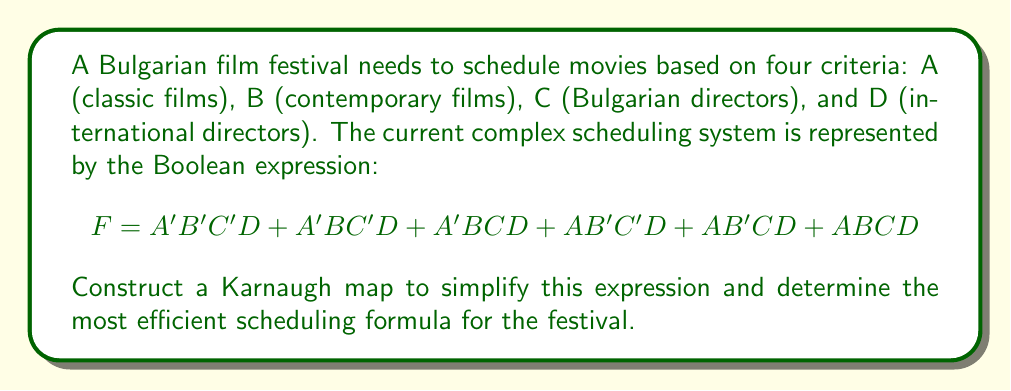Show me your answer to this math problem. Step 1: Create a 4-variable Karnaugh map with 16 cells (4x4 grid).

[asy]
unitsize(1cm);
draw((0,0)--(4,0)--(4,4)--(0,4)--cycle);
draw((0,1)--(4,1));
draw((0,2)--(4,2));
draw((0,3)--(4,3));
draw((1,0)--(1,4));
draw((2,0)--(2,4));
draw((3,0)--(3,4));
label("00", (0.5,4.5));
label("01", (1.5,4.5));
label("11", (2.5,4.5));
label("10", (3.5,4.5));
label("00", (-0.5,3.5));
label("01", (-0.5,2.5));
label("11", (-0.5,1.5));
label("10", (-0.5,0.5));
label("AB", (-0.5,4.5));
label("CD", (4.5,4.5));
[/asy]

Step 2: Fill in the Karnaugh map based on the given expression.

[asy]
unitsize(1cm);
draw((0,0)--(4,0)--(4,4)--(0,4)--cycle);
draw((0,1)--(4,1));
draw((0,2)--(4,2));
draw((0,3)--(4,3));
draw((1,0)--(1,4));
draw((2,0)--(2,4));
draw((3,0)--(3,4));
label("00", (0.5,4.5));
label("01", (1.5,4.5));
label("11", (2.5,4.5));
label("10", (3.5,4.5));
label("00", (-0.5,3.5));
label("01", (-0.5,2.5));
label("11", (-0.5,1.5));
label("10", (-0.5,0.5));
label("AB", (-0.5,4.5));
label("CD", (4.5,4.5));
label("1", (0.5,0.5));
label("1", (1.5,0.5));
label("1", (1.5,1.5));
label("1", (2.5,0.5));
label("1", (2.5,1.5));
label("1", (3.5,1.5));
[/asy]

Step 3: Identify the largest possible groupings of 1s in the map. We can see two groups:
1. A group of four 1s in the bottom row (CD = 01 and CD = 11)
2. A group of two 1s in the right column (AB = 11)

Step 4: Write the simplified Boolean expression based on these groupings:
1. The group of four 1s: $B'D$
2. The group of two 1s: $ACD$

Step 5: Combine the expressions using the OR operator:

$F = B'D + ACD$

This simplified expression represents the most efficient scheduling formula for the festival.
Answer: $F = B'D + ACD$ 